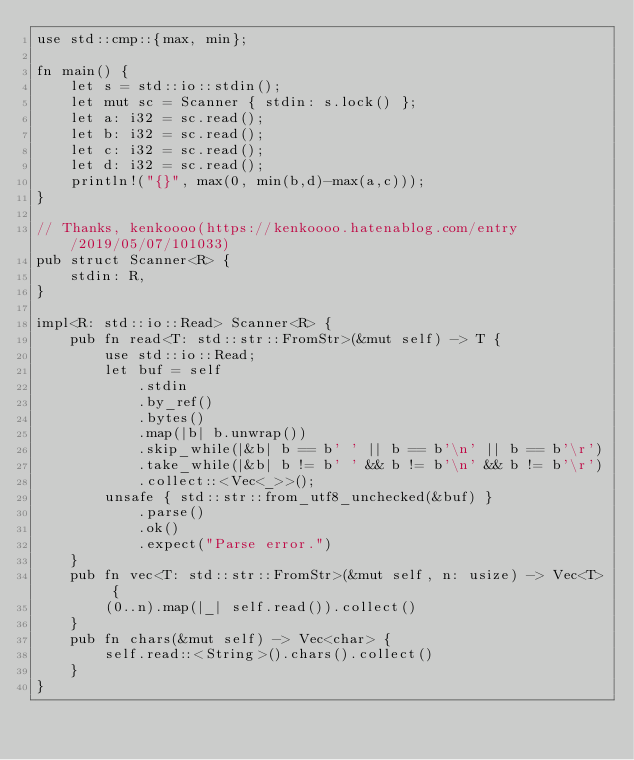<code> <loc_0><loc_0><loc_500><loc_500><_Rust_>use std::cmp::{max, min};

fn main() {
    let s = std::io::stdin();
    let mut sc = Scanner { stdin: s.lock() };
    let a: i32 = sc.read();
    let b: i32 = sc.read();
    let c: i32 = sc.read();
    let d: i32 = sc.read();
    println!("{}", max(0, min(b,d)-max(a,c)));
}

// Thanks, kenkoooo(https://kenkoooo.hatenablog.com/entry/2019/05/07/101033)
pub struct Scanner<R> {
    stdin: R,
}

impl<R: std::io::Read> Scanner<R> {
    pub fn read<T: std::str::FromStr>(&mut self) -> T {
        use std::io::Read;
        let buf = self
            .stdin
            .by_ref()
            .bytes()
            .map(|b| b.unwrap())
            .skip_while(|&b| b == b' ' || b == b'\n' || b == b'\r')
            .take_while(|&b| b != b' ' && b != b'\n' && b != b'\r')
            .collect::<Vec<_>>();
        unsafe { std::str::from_utf8_unchecked(&buf) }
            .parse()
            .ok()
            .expect("Parse error.")
    }
    pub fn vec<T: std::str::FromStr>(&mut self, n: usize) -> Vec<T> {
        (0..n).map(|_| self.read()).collect()
    }
    pub fn chars(&mut self) -> Vec<char> {
        self.read::<String>().chars().collect()
    }
}</code> 